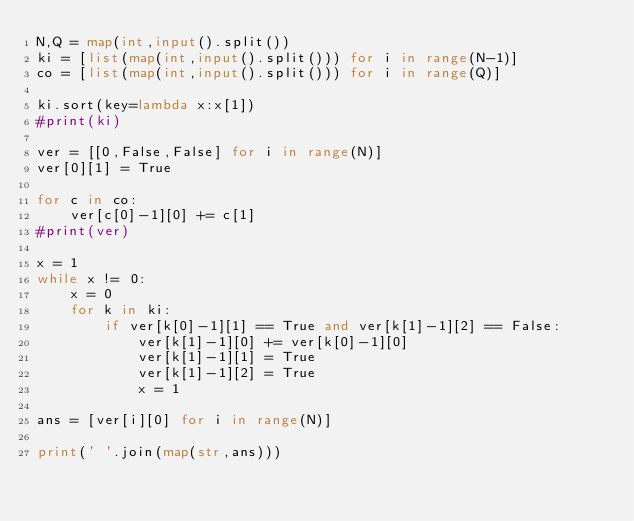Convert code to text. <code><loc_0><loc_0><loc_500><loc_500><_Python_>N,Q = map(int,input().split())
ki = [list(map(int,input().split())) for i in range(N-1)]
co = [list(map(int,input().split())) for i in range(Q)]

ki.sort(key=lambda x:x[1])
#print(ki)

ver = [[0,False,False] for i in range(N)]
ver[0][1] = True

for c in co:
    ver[c[0]-1][0] += c[1]
#print(ver)

x = 1
while x != 0:
    x = 0
    for k in ki:
        if ver[k[0]-1][1] == True and ver[k[1]-1][2] == False:
            ver[k[1]-1][0] += ver[k[0]-1][0]
            ver[k[1]-1][1] = True
            ver[k[1]-1][2] = True
            x = 1

ans = [ver[i][0] for i in range(N)]

print(' '.join(map(str,ans)))
</code> 